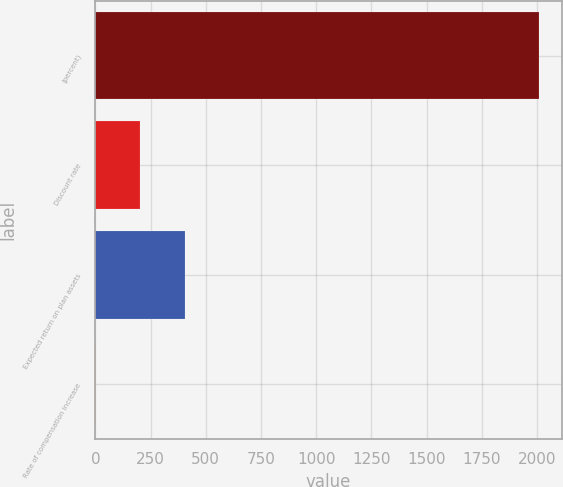<chart> <loc_0><loc_0><loc_500><loc_500><bar_chart><fcel>(percent)<fcel>Discount rate<fcel>Expected return on plan assets<fcel>Rate of compensation increase<nl><fcel>2011<fcel>203.62<fcel>404.44<fcel>2.8<nl></chart> 